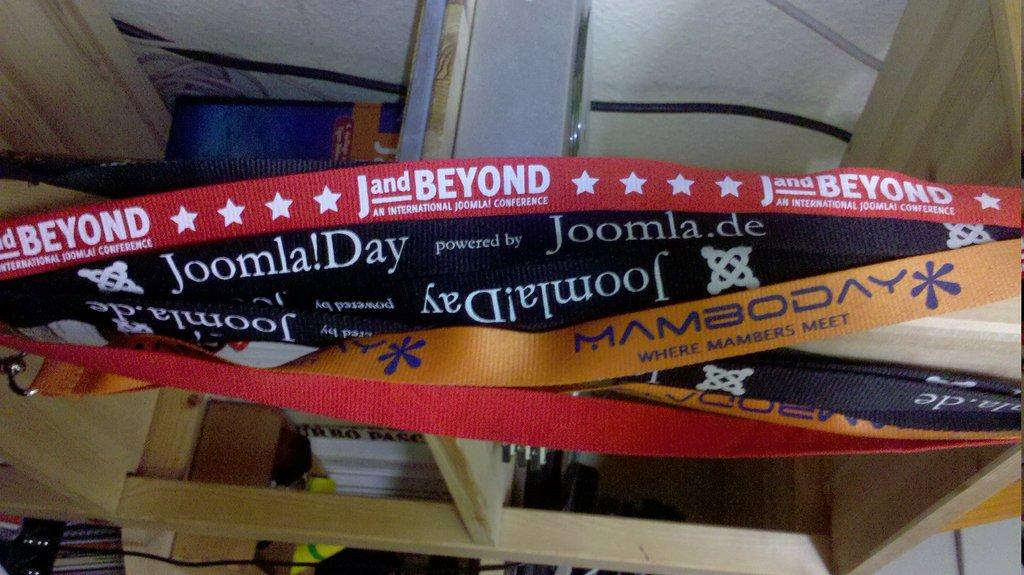Provide a one-sentence caption for the provided image. 5 or 6 different streamers with different saying one for example says Joomla! Day. 